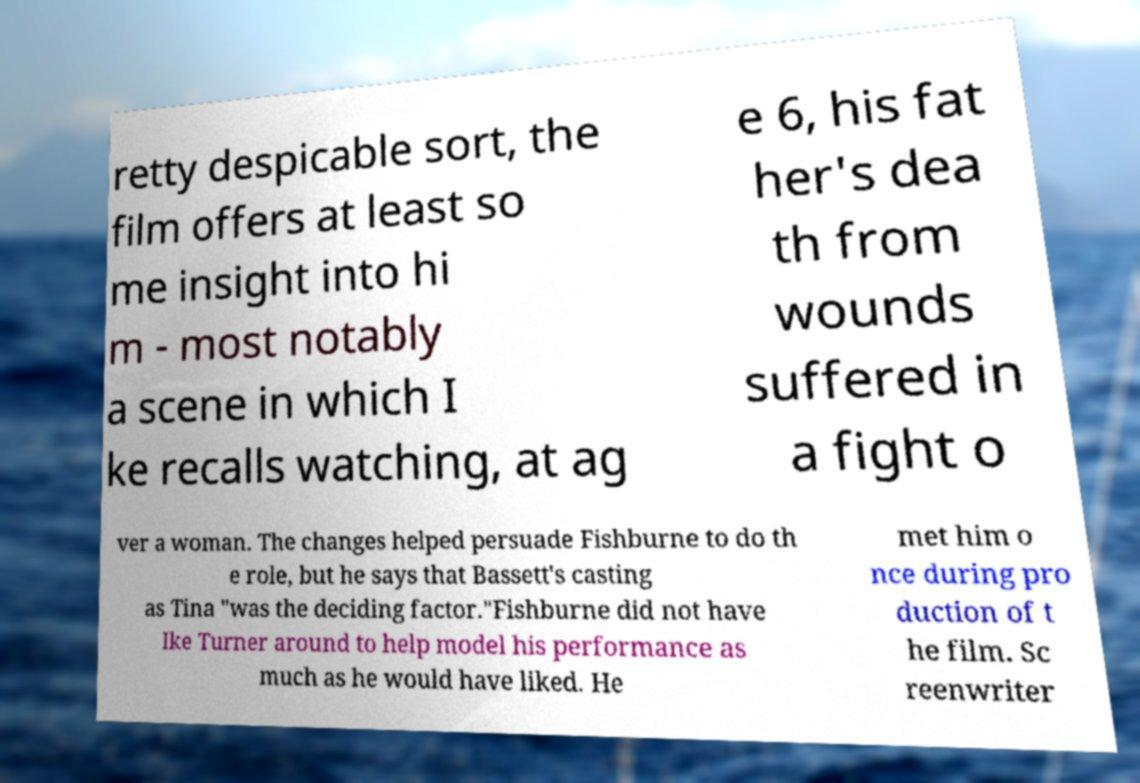What messages or text are displayed in this image? I need them in a readable, typed format. retty despicable sort, the film offers at least so me insight into hi m - most notably a scene in which I ke recalls watching, at ag e 6, his fat her's dea th from wounds suffered in a fight o ver a woman. The changes helped persuade Fishburne to do th e role, but he says that Bassett's casting as Tina "was the deciding factor."Fishburne did not have Ike Turner around to help model his performance as much as he would have liked. He met him o nce during pro duction of t he film. Sc reenwriter 